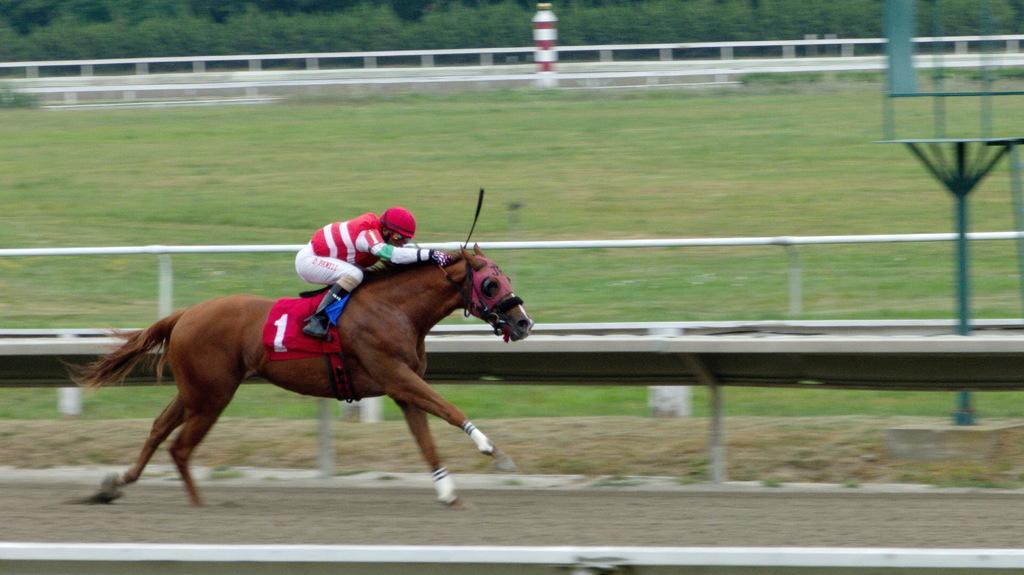In one or two sentences, can you explain what this image depicts? In this image there is a man who is riding the horse in the ground. Beside the horse there is a fence. In the ground there is grass. In the background there are trees. 